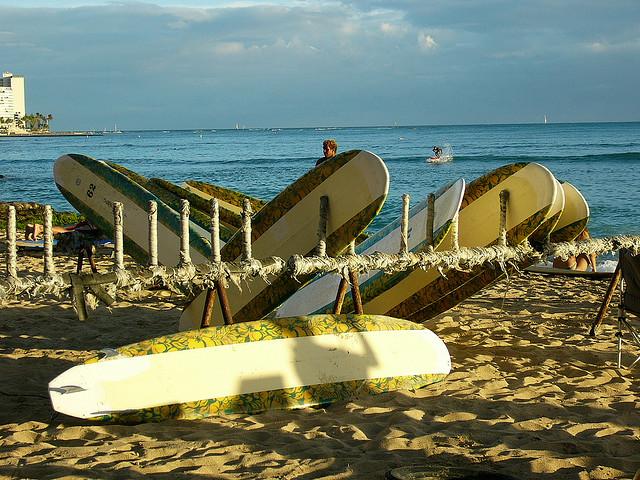What are the dark stripes on the ground?
Write a very short answer. Shadows. Is there sand?
Answer briefly. Yes. How can you tell this is a warm, tropical environment?
Quick response, please. Yes. 